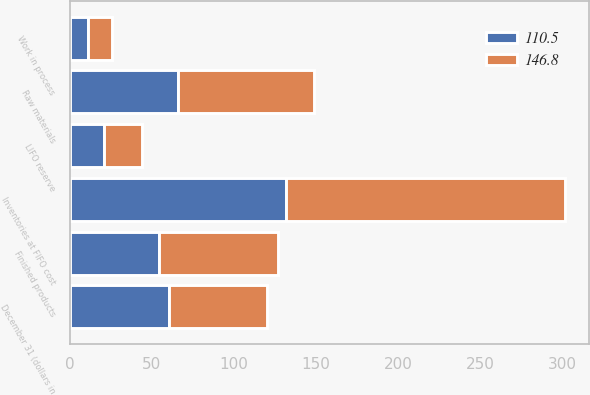<chart> <loc_0><loc_0><loc_500><loc_500><stacked_bar_chart><ecel><fcel>December 31 (dollars in<fcel>Finished products<fcel>Work in process<fcel>Raw materials<fcel>Inventories at FIFO cost<fcel>LIFO reserve<nl><fcel>146.8<fcel>60.15<fcel>72.7<fcel>14.4<fcel>82.7<fcel>169.8<fcel>23<nl><fcel>110.5<fcel>60.15<fcel>54.1<fcel>11.3<fcel>66.2<fcel>131.6<fcel>21.1<nl></chart> 